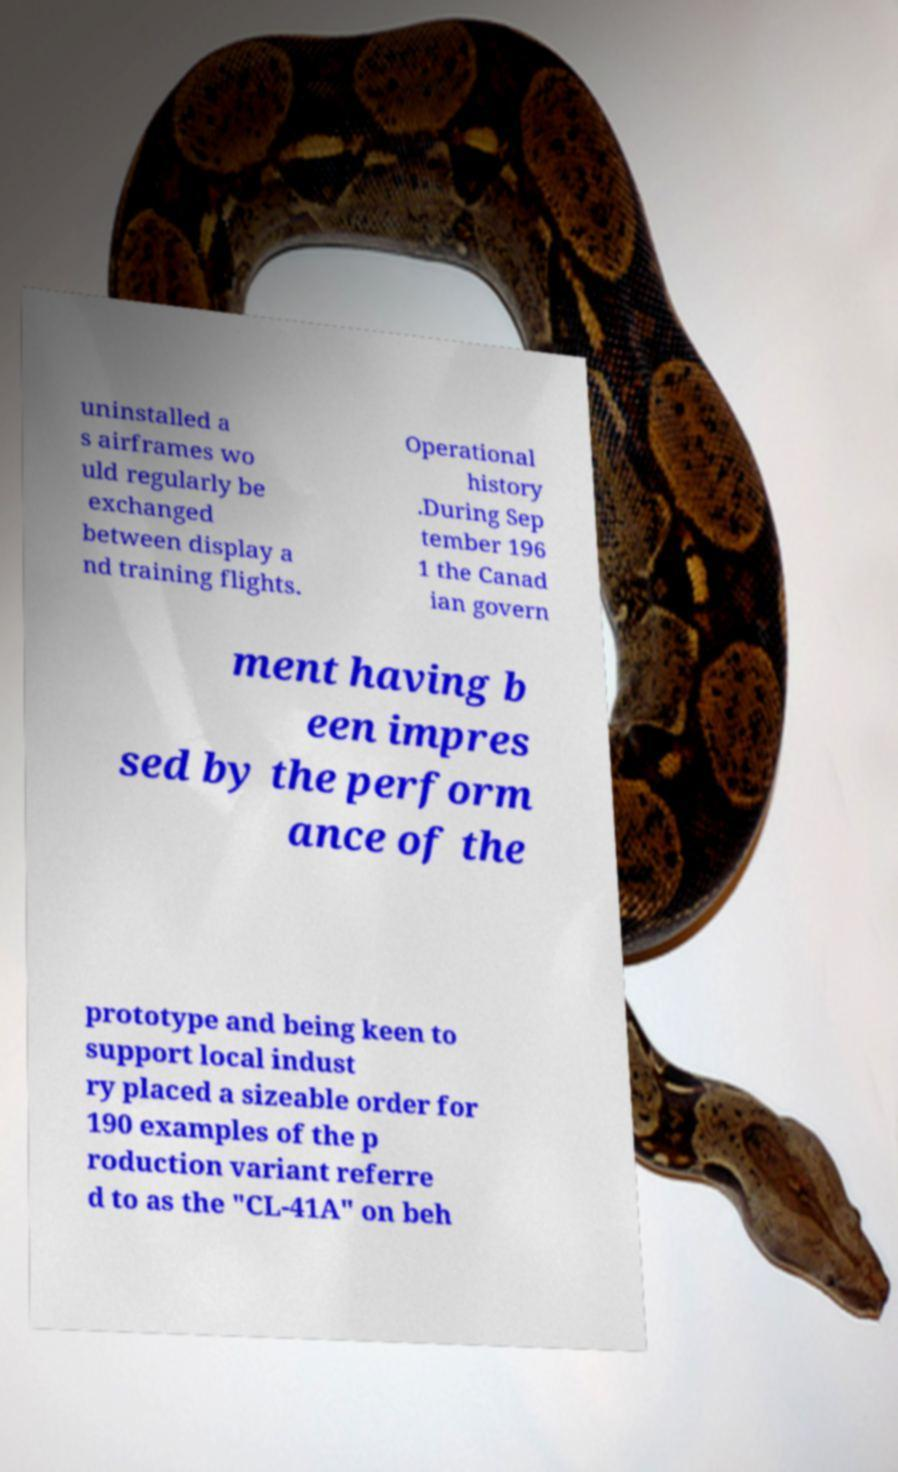I need the written content from this picture converted into text. Can you do that? uninstalled a s airframes wo uld regularly be exchanged between display a nd training flights. Operational history .During Sep tember 196 1 the Canad ian govern ment having b een impres sed by the perform ance of the prototype and being keen to support local indust ry placed a sizeable order for 190 examples of the p roduction variant referre d to as the "CL-41A" on beh 